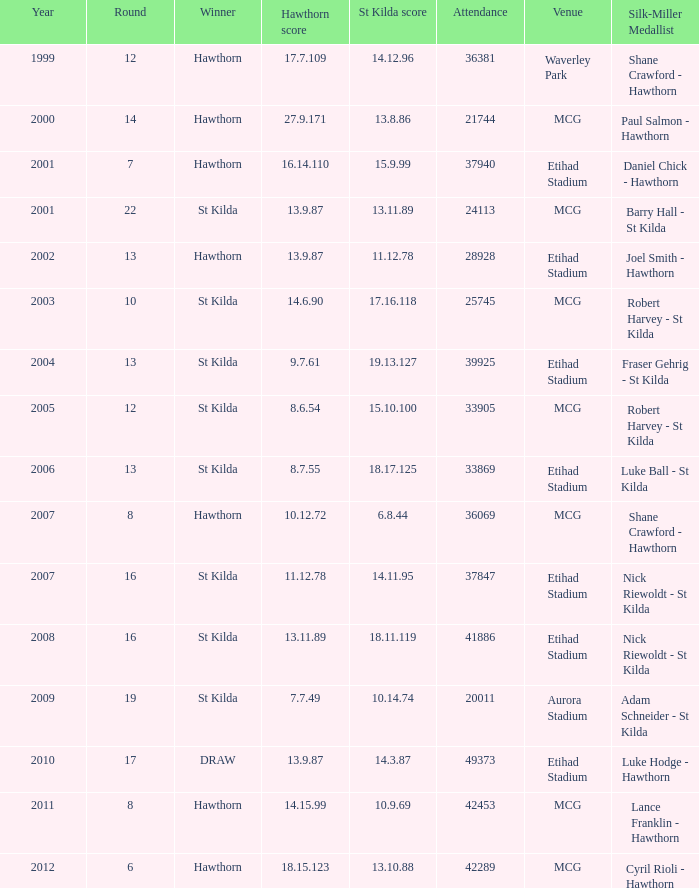What is the turnout when the st kilda score is 1 42289.0. 